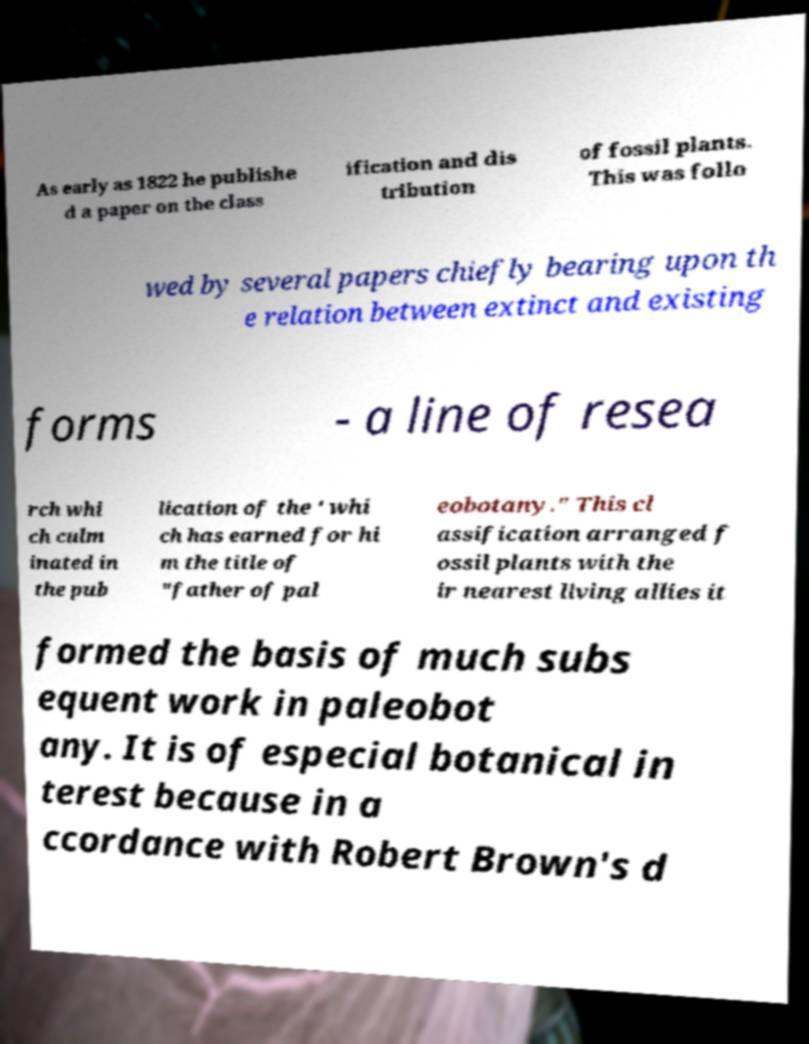Please identify and transcribe the text found in this image. As early as 1822 he publishe d a paper on the class ification and dis tribution of fossil plants. This was follo wed by several papers chiefly bearing upon th e relation between extinct and existing forms - a line of resea rch whi ch culm inated in the pub lication of the ' whi ch has earned for hi m the title of "father of pal eobotany." This cl assification arranged f ossil plants with the ir nearest living allies it formed the basis of much subs equent work in paleobot any. It is of especial botanical in terest because in a ccordance with Robert Brown's d 